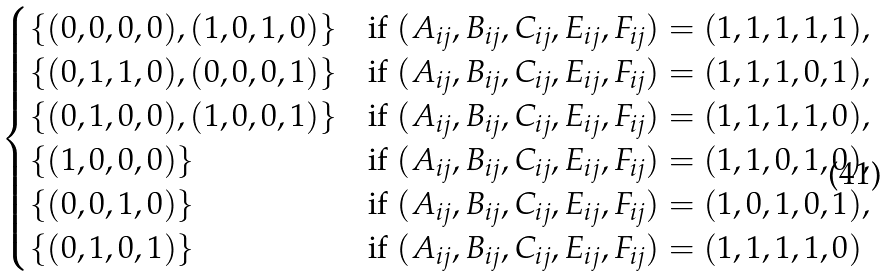<formula> <loc_0><loc_0><loc_500><loc_500>\begin{cases} \left \{ ( 0 , 0 , 0 , 0 ) , ( 1 , 0 , 1 , 0 ) \right \} & \text {if } ( A _ { i j } , B _ { i j } , C _ { i j } , E _ { i j } , F _ { i j } ) = ( 1 , 1 , 1 , 1 , 1 ) , \\ \left \{ ( 0 , 1 , 1 , 0 ) , ( 0 , 0 , 0 , 1 ) \right \} & \text {if } ( A _ { i j } , B _ { i j } , C _ { i j } , E _ { i j } , F _ { i j } ) = ( 1 , 1 , 1 , 0 , 1 ) , \\ \left \{ ( 0 , 1 , 0 , 0 ) , ( 1 , 0 , 0 , 1 ) \right \} & \text {if } ( A _ { i j } , B _ { i j } , C _ { i j } , E _ { i j } , F _ { i j } ) = ( 1 , 1 , 1 , 1 , 0 ) , \\ \left \{ ( 1 , 0 , 0 , 0 ) \right \} & \text {if } ( A _ { i j } , B _ { i j } , C _ { i j } , E _ { i j } , F _ { i j } ) = ( 1 , 1 , 0 , 1 , 0 ) , \\ \left \{ ( 0 , 0 , 1 , 0 ) \right \} & \text {if } ( A _ { i j } , B _ { i j } , C _ { i j } , E _ { i j } , F _ { i j } ) = ( 1 , 0 , 1 , 0 , 1 ) , \\ \left \{ ( 0 , 1 , 0 , 1 ) \right \} & \text {if } ( A _ { i j } , B _ { i j } , C _ { i j } , E _ { i j } , F _ { i j } ) = ( 1 , 1 , 1 , 1 , 0 ) \\ \end{cases}</formula> 